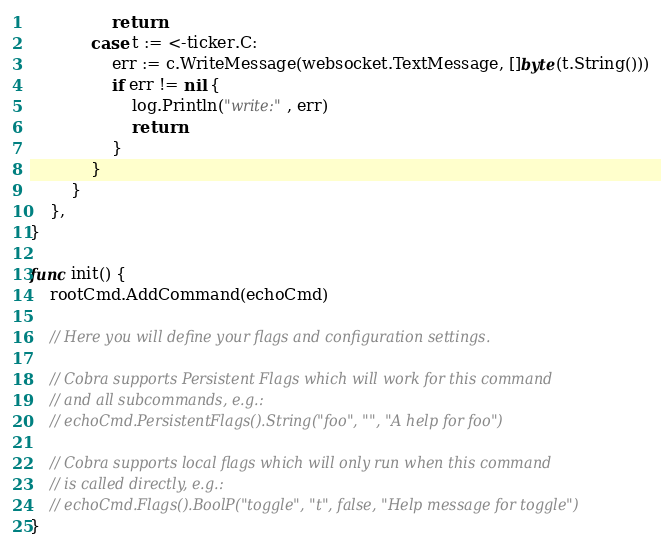Convert code to text. <code><loc_0><loc_0><loc_500><loc_500><_Go_>				return
			case t := <-ticker.C:
				err := c.WriteMessage(websocket.TextMessage, []byte(t.String()))
				if err != nil {
					log.Println("write:", err)
					return
				}
			}
		}
	},
}

func init() {
	rootCmd.AddCommand(echoCmd)

	// Here you will define your flags and configuration settings.

	// Cobra supports Persistent Flags which will work for this command
	// and all subcommands, e.g.:
	// echoCmd.PersistentFlags().String("foo", "", "A help for foo")

	// Cobra supports local flags which will only run when this command
	// is called directly, e.g.:
	// echoCmd.Flags().BoolP("toggle", "t", false, "Help message for toggle")
}
</code> 